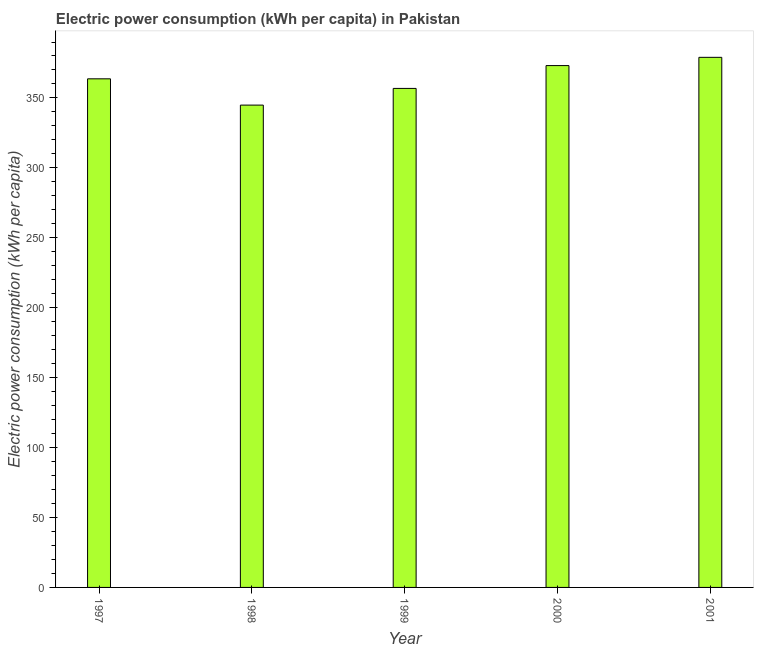Does the graph contain any zero values?
Give a very brief answer. No. What is the title of the graph?
Keep it short and to the point. Electric power consumption (kWh per capita) in Pakistan. What is the label or title of the X-axis?
Give a very brief answer. Year. What is the label or title of the Y-axis?
Give a very brief answer. Electric power consumption (kWh per capita). What is the electric power consumption in 1999?
Offer a terse response. 356.82. Across all years, what is the maximum electric power consumption?
Offer a very short reply. 379.04. Across all years, what is the minimum electric power consumption?
Your answer should be compact. 344.88. In which year was the electric power consumption minimum?
Offer a terse response. 1998. What is the sum of the electric power consumption?
Keep it short and to the point. 1817.55. What is the difference between the electric power consumption in 1997 and 1998?
Your response must be concise. 18.79. What is the average electric power consumption per year?
Your response must be concise. 363.51. What is the median electric power consumption?
Offer a very short reply. 363.68. In how many years, is the electric power consumption greater than 160 kWh per capita?
Provide a short and direct response. 5. What is the ratio of the electric power consumption in 1999 to that in 2001?
Your answer should be very brief. 0.94. What is the difference between the highest and the second highest electric power consumption?
Your answer should be very brief. 5.91. Is the sum of the electric power consumption in 1997 and 2000 greater than the maximum electric power consumption across all years?
Your answer should be very brief. Yes. What is the difference between the highest and the lowest electric power consumption?
Your response must be concise. 34.16. In how many years, is the electric power consumption greater than the average electric power consumption taken over all years?
Your answer should be compact. 3. Are the values on the major ticks of Y-axis written in scientific E-notation?
Provide a succinct answer. No. What is the Electric power consumption (kWh per capita) in 1997?
Give a very brief answer. 363.68. What is the Electric power consumption (kWh per capita) of 1998?
Your answer should be compact. 344.88. What is the Electric power consumption (kWh per capita) of 1999?
Offer a very short reply. 356.82. What is the Electric power consumption (kWh per capita) in 2000?
Your answer should be very brief. 373.13. What is the Electric power consumption (kWh per capita) of 2001?
Your answer should be compact. 379.04. What is the difference between the Electric power consumption (kWh per capita) in 1997 and 1998?
Your response must be concise. 18.79. What is the difference between the Electric power consumption (kWh per capita) in 1997 and 1999?
Your response must be concise. 6.86. What is the difference between the Electric power consumption (kWh per capita) in 1997 and 2000?
Your answer should be compact. -9.46. What is the difference between the Electric power consumption (kWh per capita) in 1997 and 2001?
Make the answer very short. -15.37. What is the difference between the Electric power consumption (kWh per capita) in 1998 and 1999?
Give a very brief answer. -11.94. What is the difference between the Electric power consumption (kWh per capita) in 1998 and 2000?
Ensure brevity in your answer.  -28.25. What is the difference between the Electric power consumption (kWh per capita) in 1998 and 2001?
Your response must be concise. -34.16. What is the difference between the Electric power consumption (kWh per capita) in 1999 and 2000?
Your response must be concise. -16.32. What is the difference between the Electric power consumption (kWh per capita) in 1999 and 2001?
Offer a terse response. -22.22. What is the difference between the Electric power consumption (kWh per capita) in 2000 and 2001?
Keep it short and to the point. -5.91. What is the ratio of the Electric power consumption (kWh per capita) in 1997 to that in 1998?
Keep it short and to the point. 1.05. What is the ratio of the Electric power consumption (kWh per capita) in 1997 to that in 1999?
Offer a terse response. 1.02. What is the ratio of the Electric power consumption (kWh per capita) in 1997 to that in 2001?
Give a very brief answer. 0.96. What is the ratio of the Electric power consumption (kWh per capita) in 1998 to that in 2000?
Ensure brevity in your answer.  0.92. What is the ratio of the Electric power consumption (kWh per capita) in 1998 to that in 2001?
Offer a very short reply. 0.91. What is the ratio of the Electric power consumption (kWh per capita) in 1999 to that in 2000?
Your response must be concise. 0.96. What is the ratio of the Electric power consumption (kWh per capita) in 1999 to that in 2001?
Make the answer very short. 0.94. 